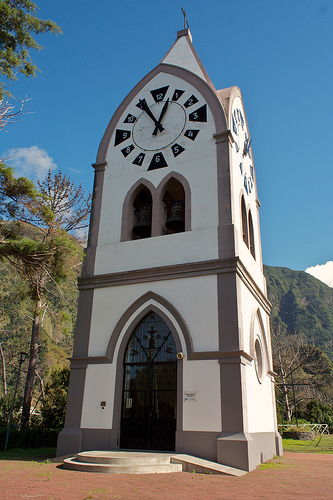What is under the clock in the top of the picture? Directly under the clock, there is a bell. 